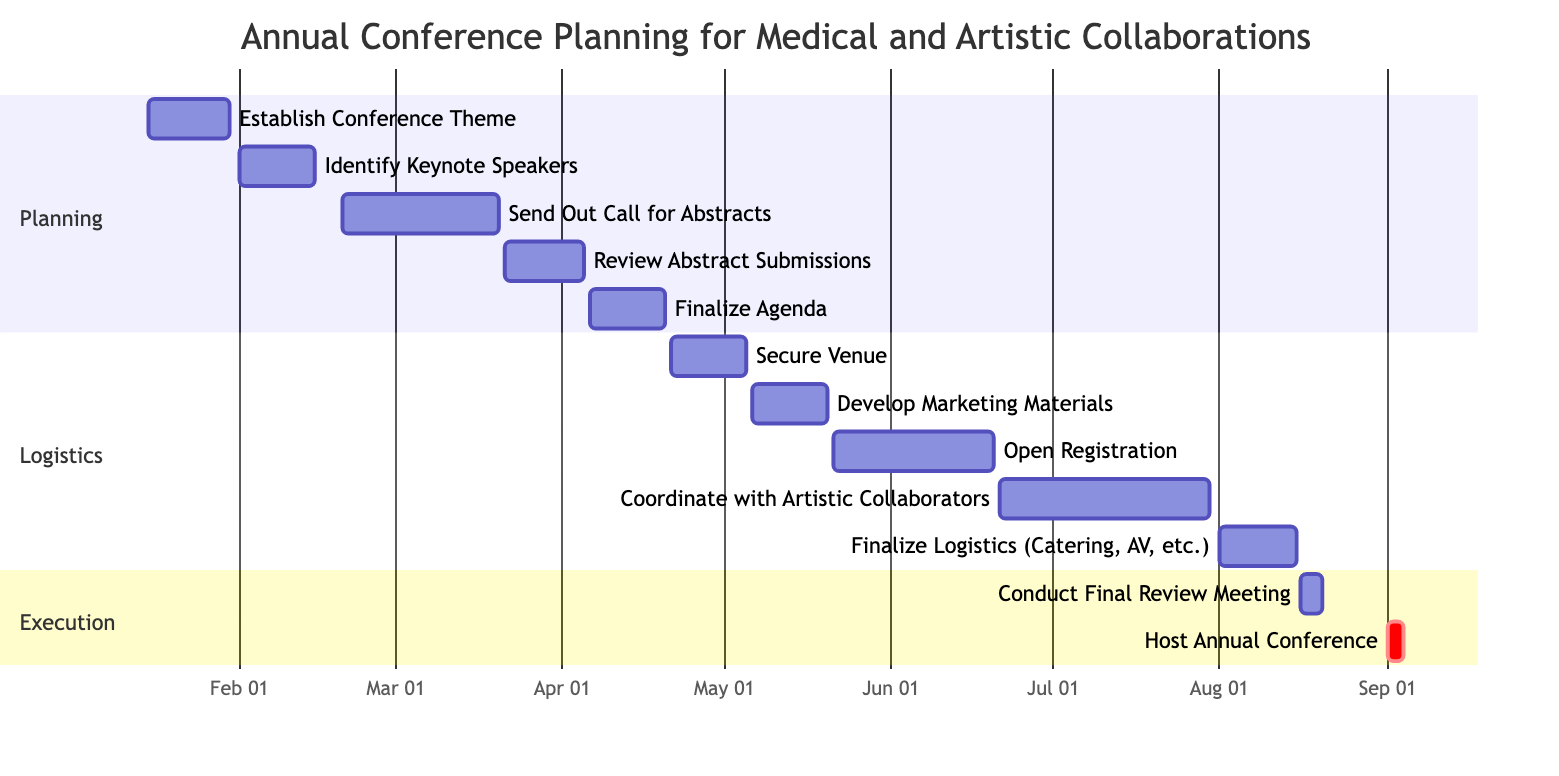What is the start date for the task "Establish Conference Theme"? The task "Establish Conference Theme" starts on January 15, 2024, as indicated in the Gantt chart.
Answer: January 15, 2024 What is the end date for the task "Open Registration"? According to the Gantt chart, the task "Open Registration" ends on June 20, 2024.
Answer: June 20, 2024 How many tasks are scheduled between February and April 2024? Counting the tasks that fall within February to April 2024, we have "Identify Keynote Speakers," "Send Out Call for Abstracts," "Review Abstract Submissions," and "Finalize Agenda," totaling four tasks.
Answer: 4 Which task directly follows "Send Out Call for Abstracts"? After "Send Out Call for Abstracts," the next task is "Review Abstract Submissions," as per the timeline shown in the Gantt chart.
Answer: Review Abstract Submissions What is the duration of the task "Coordinate with Artistic Collaborators"? The task "Coordinate with Artistic Collaborators" starts on June 21, 2024, and ends on July 30, 2024, which calculates to a duration of 39 days.
Answer: 39 days When does the "Host Annual Conference" task start? The "Host Annual Conference" task is scheduled to start on September 1, 2024, as shown on the Gantt chart.
Answer: September 1, 2024 Which task has the latest start date? The task "Conduct Final Review Meeting" has the latest start date of August 16, 2024, according to the Gantt chart.
Answer: Conduct Final Review Meeting Which section includes "Secure Venue"? The task "Secure Venue" is included in the "Logistics" section of the Gantt chart.
Answer: Logistics How many days are allocated for the "Finalize Logistics (Catering, AV, etc.)" task? The task "Finalize Logistics (Catering, AV, etc.)" has a duration of 14 days, starting from August 1, 2024.
Answer: 14 days 